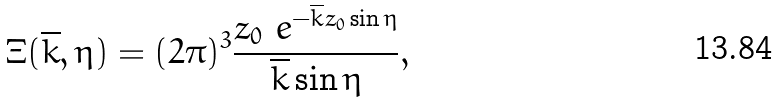<formula> <loc_0><loc_0><loc_500><loc_500>\Xi ( \overline { k } , \eta ) = ( 2 \pi ) ^ { 3 } \frac { z _ { 0 } \ e ^ { - \overline { k } z _ { 0 } \sin \eta } } { \overline { k } \sin \eta } ,</formula> 